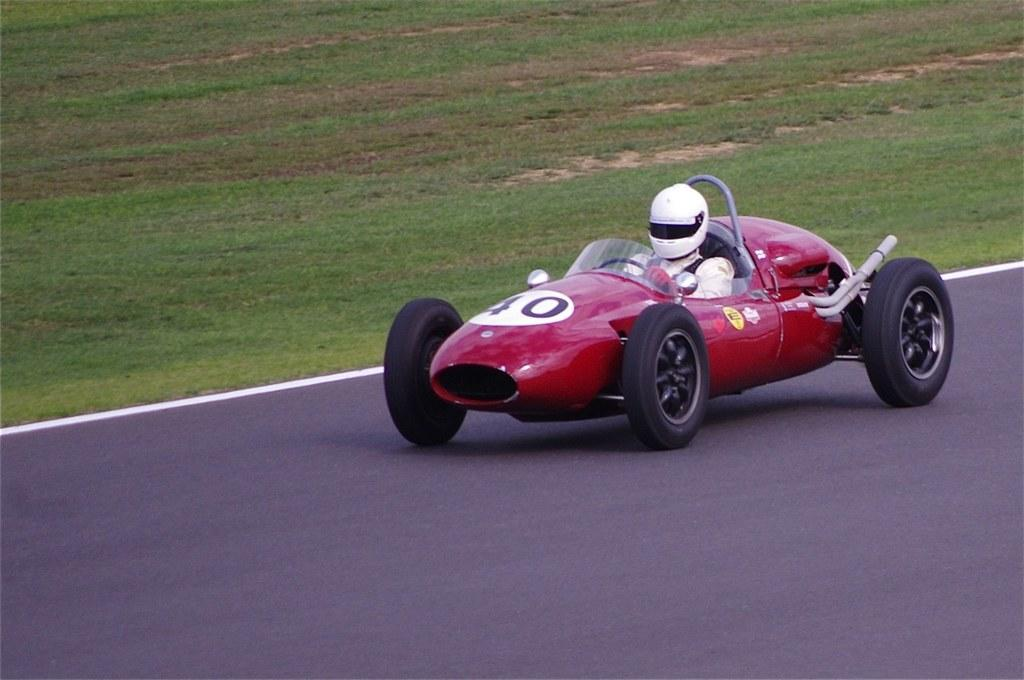What color is the car in the image? The car in the image is red. Who is inside the car? A person is sitting inside the car. What is the person wearing? The person is wearing a white helmet. Where is the car located? The car is on the road. What type of creature is the person reading about in the image? There is no indication in the image that the person is reading about any creature. 